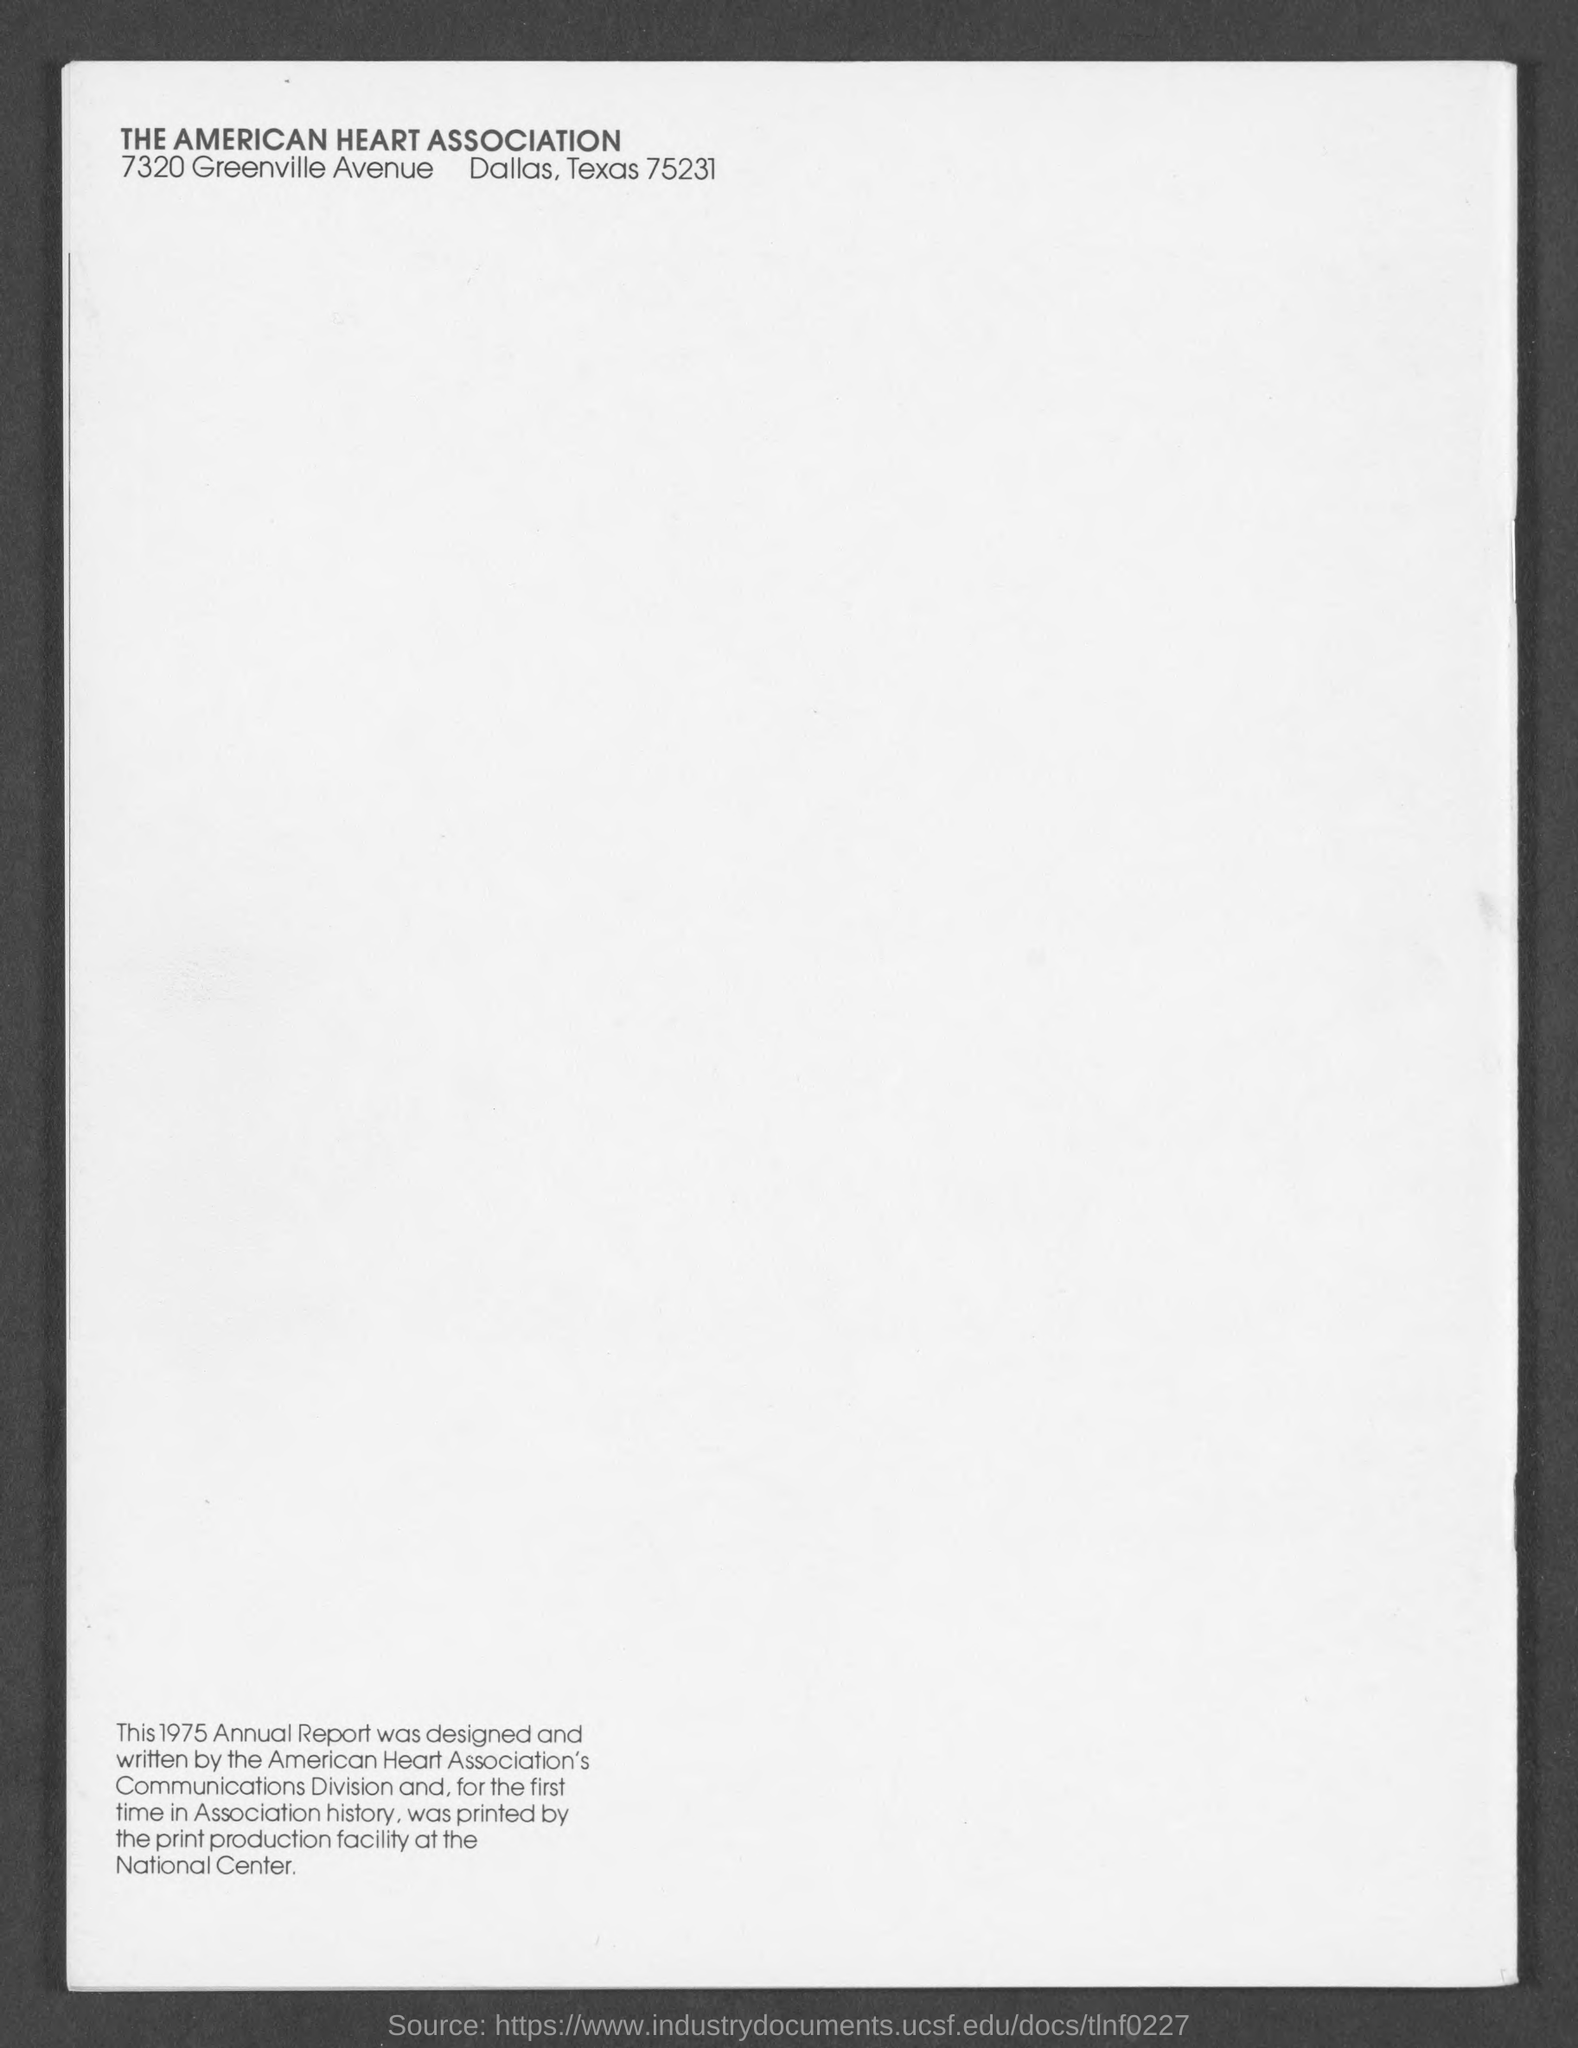List a handful of essential elements in this visual. The American Heart Association is the name of the association mentioned in the given form. 